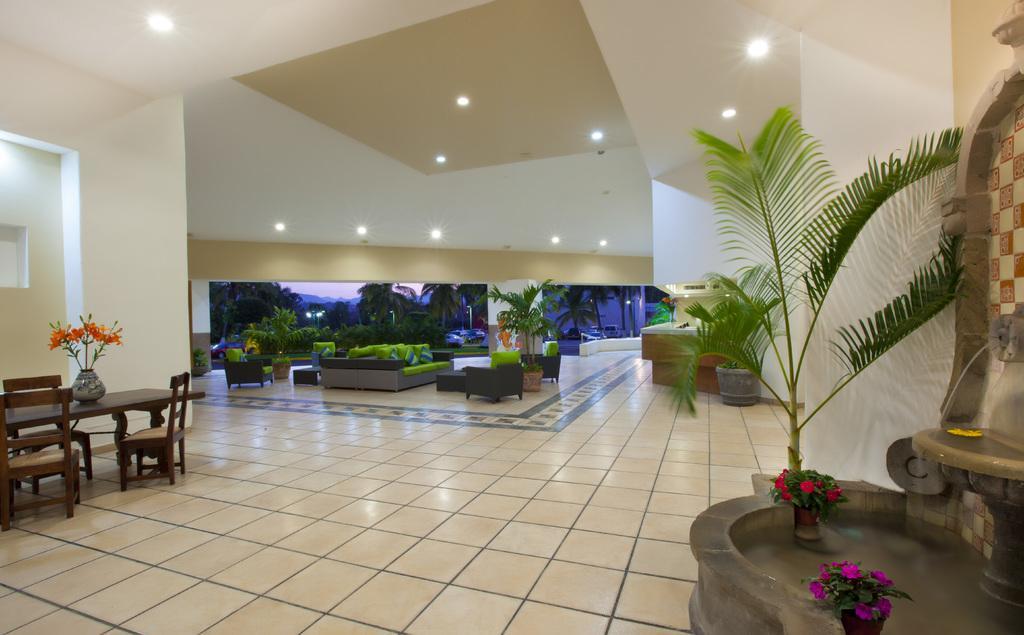Please provide a concise description of this image. In this image we can see a dining table, and chairs on the floor, there are flower pots, there is the water in the container, there is a sofa, and pillows on it, there are trees, at above there are ceiling lights. 